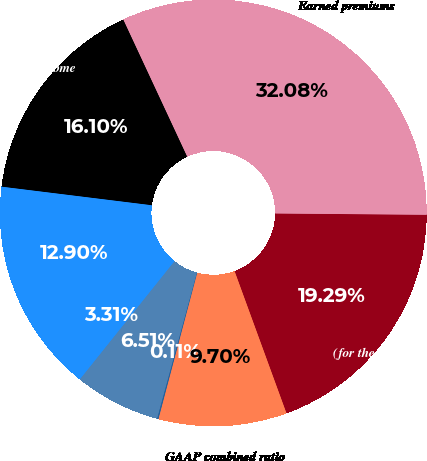Convert chart. <chart><loc_0><loc_0><loc_500><loc_500><pie_chart><fcel>(for the year ended December<fcel>Earned premiums<fcel>Net investment income<fcel>Fee income<fcel>Other revenues<fcel>Loss and lossadjustment<fcel>Underwriting expense ratio<fcel>GAAP combined ratio<nl><fcel>19.29%<fcel>32.08%<fcel>16.1%<fcel>12.9%<fcel>3.31%<fcel>6.51%<fcel>0.11%<fcel>9.7%<nl></chart> 